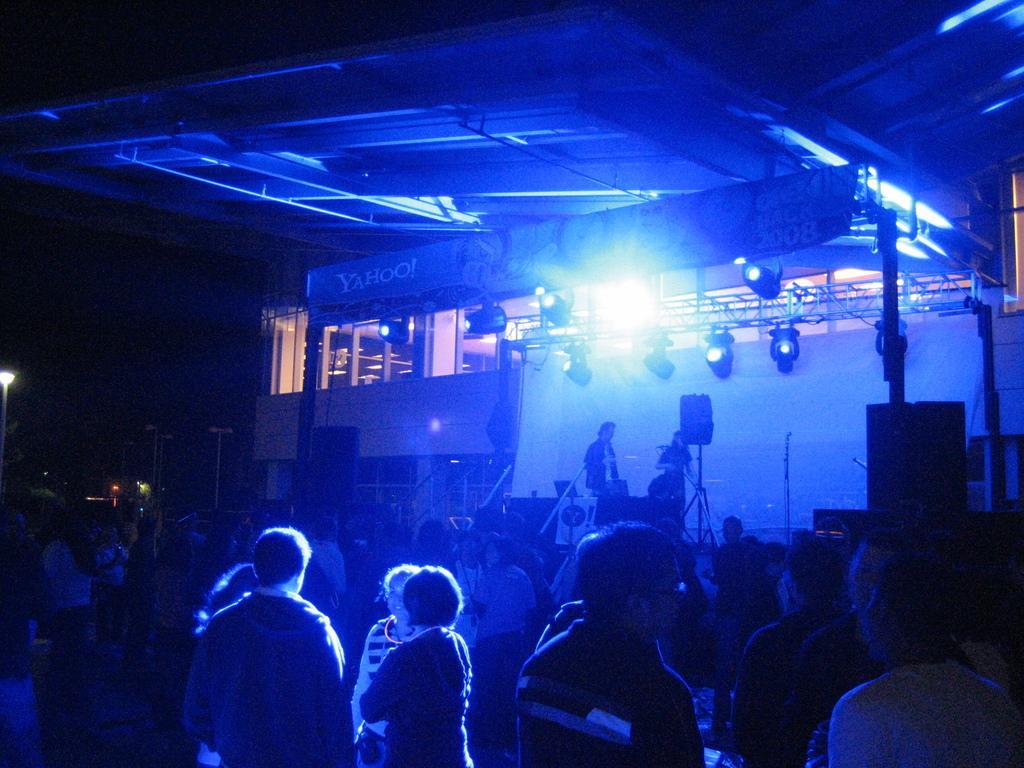Can you describe this image briefly? In this picture we can see a group of people standing were two are on the stage, speakers, lights, banners, building, poles and some objects and in the background it is dark. 